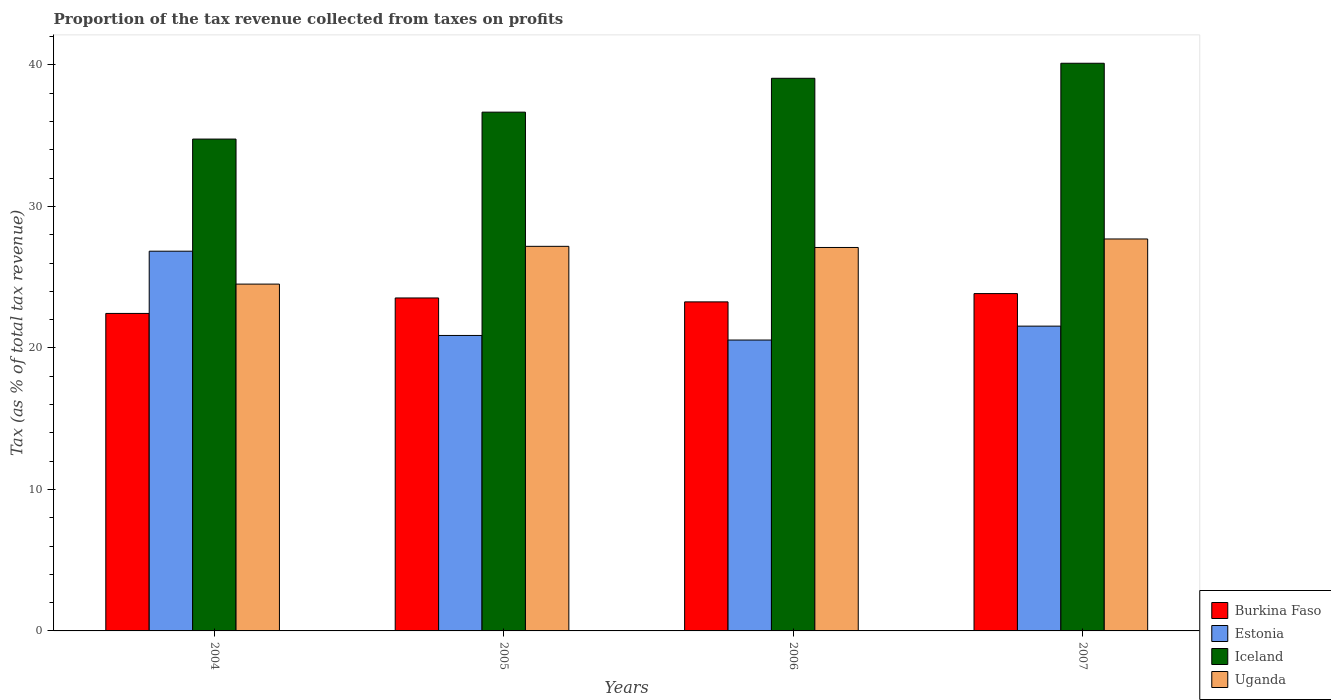How many different coloured bars are there?
Ensure brevity in your answer.  4. How many groups of bars are there?
Provide a succinct answer. 4. How many bars are there on the 4th tick from the right?
Offer a very short reply. 4. What is the proportion of the tax revenue collected in Burkina Faso in 2005?
Give a very brief answer. 23.53. Across all years, what is the maximum proportion of the tax revenue collected in Iceland?
Your answer should be compact. 40.12. Across all years, what is the minimum proportion of the tax revenue collected in Iceland?
Ensure brevity in your answer.  34.76. In which year was the proportion of the tax revenue collected in Iceland minimum?
Provide a succinct answer. 2004. What is the total proportion of the tax revenue collected in Iceland in the graph?
Your answer should be compact. 150.61. What is the difference between the proportion of the tax revenue collected in Estonia in 2006 and that in 2007?
Your answer should be compact. -0.98. What is the difference between the proportion of the tax revenue collected in Iceland in 2005 and the proportion of the tax revenue collected in Uganda in 2006?
Give a very brief answer. 9.56. What is the average proportion of the tax revenue collected in Burkina Faso per year?
Your response must be concise. 23.27. In the year 2006, what is the difference between the proportion of the tax revenue collected in Uganda and proportion of the tax revenue collected in Estonia?
Ensure brevity in your answer.  6.54. What is the ratio of the proportion of the tax revenue collected in Burkina Faso in 2006 to that in 2007?
Keep it short and to the point. 0.98. What is the difference between the highest and the second highest proportion of the tax revenue collected in Iceland?
Your answer should be compact. 1.06. What is the difference between the highest and the lowest proportion of the tax revenue collected in Uganda?
Offer a terse response. 3.19. Is the sum of the proportion of the tax revenue collected in Burkina Faso in 2004 and 2006 greater than the maximum proportion of the tax revenue collected in Uganda across all years?
Your answer should be compact. Yes. Is it the case that in every year, the sum of the proportion of the tax revenue collected in Iceland and proportion of the tax revenue collected in Uganda is greater than the sum of proportion of the tax revenue collected in Estonia and proportion of the tax revenue collected in Burkina Faso?
Provide a short and direct response. Yes. What does the 2nd bar from the left in 2006 represents?
Offer a terse response. Estonia. What does the 3rd bar from the right in 2004 represents?
Provide a succinct answer. Estonia. How many bars are there?
Your response must be concise. 16. How many years are there in the graph?
Ensure brevity in your answer.  4. Does the graph contain any zero values?
Provide a short and direct response. No. How many legend labels are there?
Give a very brief answer. 4. How are the legend labels stacked?
Give a very brief answer. Vertical. What is the title of the graph?
Make the answer very short. Proportion of the tax revenue collected from taxes on profits. Does "Albania" appear as one of the legend labels in the graph?
Offer a very short reply. No. What is the label or title of the Y-axis?
Offer a terse response. Tax (as % of total tax revenue). What is the Tax (as % of total tax revenue) in Burkina Faso in 2004?
Your response must be concise. 22.44. What is the Tax (as % of total tax revenue) in Estonia in 2004?
Your answer should be very brief. 26.84. What is the Tax (as % of total tax revenue) of Iceland in 2004?
Give a very brief answer. 34.76. What is the Tax (as % of total tax revenue) of Uganda in 2004?
Provide a succinct answer. 24.51. What is the Tax (as % of total tax revenue) in Burkina Faso in 2005?
Offer a very short reply. 23.53. What is the Tax (as % of total tax revenue) of Estonia in 2005?
Provide a succinct answer. 20.88. What is the Tax (as % of total tax revenue) in Iceland in 2005?
Your answer should be very brief. 36.66. What is the Tax (as % of total tax revenue) in Uganda in 2005?
Ensure brevity in your answer.  27.18. What is the Tax (as % of total tax revenue) in Burkina Faso in 2006?
Ensure brevity in your answer.  23.26. What is the Tax (as % of total tax revenue) in Estonia in 2006?
Provide a succinct answer. 20.56. What is the Tax (as % of total tax revenue) of Iceland in 2006?
Offer a terse response. 39.06. What is the Tax (as % of total tax revenue) in Uganda in 2006?
Make the answer very short. 27.1. What is the Tax (as % of total tax revenue) in Burkina Faso in 2007?
Give a very brief answer. 23.84. What is the Tax (as % of total tax revenue) in Estonia in 2007?
Offer a terse response. 21.54. What is the Tax (as % of total tax revenue) in Iceland in 2007?
Offer a very short reply. 40.12. What is the Tax (as % of total tax revenue) of Uganda in 2007?
Keep it short and to the point. 27.7. Across all years, what is the maximum Tax (as % of total tax revenue) in Burkina Faso?
Ensure brevity in your answer.  23.84. Across all years, what is the maximum Tax (as % of total tax revenue) of Estonia?
Offer a terse response. 26.84. Across all years, what is the maximum Tax (as % of total tax revenue) in Iceland?
Give a very brief answer. 40.12. Across all years, what is the maximum Tax (as % of total tax revenue) in Uganda?
Offer a terse response. 27.7. Across all years, what is the minimum Tax (as % of total tax revenue) in Burkina Faso?
Ensure brevity in your answer.  22.44. Across all years, what is the minimum Tax (as % of total tax revenue) of Estonia?
Keep it short and to the point. 20.56. Across all years, what is the minimum Tax (as % of total tax revenue) of Iceland?
Offer a very short reply. 34.76. Across all years, what is the minimum Tax (as % of total tax revenue) in Uganda?
Keep it short and to the point. 24.51. What is the total Tax (as % of total tax revenue) in Burkina Faso in the graph?
Make the answer very short. 93.07. What is the total Tax (as % of total tax revenue) of Estonia in the graph?
Provide a succinct answer. 89.82. What is the total Tax (as % of total tax revenue) of Iceland in the graph?
Provide a short and direct response. 150.61. What is the total Tax (as % of total tax revenue) in Uganda in the graph?
Your answer should be compact. 106.5. What is the difference between the Tax (as % of total tax revenue) of Burkina Faso in 2004 and that in 2005?
Keep it short and to the point. -1.09. What is the difference between the Tax (as % of total tax revenue) in Estonia in 2004 and that in 2005?
Provide a succinct answer. 5.96. What is the difference between the Tax (as % of total tax revenue) of Iceland in 2004 and that in 2005?
Provide a succinct answer. -1.9. What is the difference between the Tax (as % of total tax revenue) of Uganda in 2004 and that in 2005?
Your answer should be compact. -2.67. What is the difference between the Tax (as % of total tax revenue) of Burkina Faso in 2004 and that in 2006?
Your response must be concise. -0.82. What is the difference between the Tax (as % of total tax revenue) in Estonia in 2004 and that in 2006?
Offer a very short reply. 6.28. What is the difference between the Tax (as % of total tax revenue) of Iceland in 2004 and that in 2006?
Your answer should be very brief. -4.3. What is the difference between the Tax (as % of total tax revenue) in Uganda in 2004 and that in 2006?
Your answer should be very brief. -2.59. What is the difference between the Tax (as % of total tax revenue) in Burkina Faso in 2004 and that in 2007?
Your response must be concise. -1.4. What is the difference between the Tax (as % of total tax revenue) in Estonia in 2004 and that in 2007?
Your answer should be compact. 5.3. What is the difference between the Tax (as % of total tax revenue) of Iceland in 2004 and that in 2007?
Ensure brevity in your answer.  -5.36. What is the difference between the Tax (as % of total tax revenue) of Uganda in 2004 and that in 2007?
Your answer should be very brief. -3.19. What is the difference between the Tax (as % of total tax revenue) of Burkina Faso in 2005 and that in 2006?
Your answer should be very brief. 0.28. What is the difference between the Tax (as % of total tax revenue) of Estonia in 2005 and that in 2006?
Keep it short and to the point. 0.32. What is the difference between the Tax (as % of total tax revenue) of Iceland in 2005 and that in 2006?
Ensure brevity in your answer.  -2.39. What is the difference between the Tax (as % of total tax revenue) in Uganda in 2005 and that in 2006?
Provide a succinct answer. 0.08. What is the difference between the Tax (as % of total tax revenue) of Burkina Faso in 2005 and that in 2007?
Provide a short and direct response. -0.31. What is the difference between the Tax (as % of total tax revenue) of Estonia in 2005 and that in 2007?
Your answer should be compact. -0.66. What is the difference between the Tax (as % of total tax revenue) of Iceland in 2005 and that in 2007?
Your answer should be very brief. -3.46. What is the difference between the Tax (as % of total tax revenue) in Uganda in 2005 and that in 2007?
Give a very brief answer. -0.52. What is the difference between the Tax (as % of total tax revenue) in Burkina Faso in 2006 and that in 2007?
Give a very brief answer. -0.59. What is the difference between the Tax (as % of total tax revenue) in Estonia in 2006 and that in 2007?
Offer a terse response. -0.98. What is the difference between the Tax (as % of total tax revenue) in Iceland in 2006 and that in 2007?
Provide a short and direct response. -1.06. What is the difference between the Tax (as % of total tax revenue) in Uganda in 2006 and that in 2007?
Provide a succinct answer. -0.6. What is the difference between the Tax (as % of total tax revenue) in Burkina Faso in 2004 and the Tax (as % of total tax revenue) in Estonia in 2005?
Make the answer very short. 1.56. What is the difference between the Tax (as % of total tax revenue) of Burkina Faso in 2004 and the Tax (as % of total tax revenue) of Iceland in 2005?
Provide a succinct answer. -14.23. What is the difference between the Tax (as % of total tax revenue) of Burkina Faso in 2004 and the Tax (as % of total tax revenue) of Uganda in 2005?
Offer a very short reply. -4.74. What is the difference between the Tax (as % of total tax revenue) of Estonia in 2004 and the Tax (as % of total tax revenue) of Iceland in 2005?
Provide a succinct answer. -9.83. What is the difference between the Tax (as % of total tax revenue) of Estonia in 2004 and the Tax (as % of total tax revenue) of Uganda in 2005?
Your response must be concise. -0.34. What is the difference between the Tax (as % of total tax revenue) in Iceland in 2004 and the Tax (as % of total tax revenue) in Uganda in 2005?
Ensure brevity in your answer.  7.58. What is the difference between the Tax (as % of total tax revenue) of Burkina Faso in 2004 and the Tax (as % of total tax revenue) of Estonia in 2006?
Your response must be concise. 1.88. What is the difference between the Tax (as % of total tax revenue) of Burkina Faso in 2004 and the Tax (as % of total tax revenue) of Iceland in 2006?
Provide a succinct answer. -16.62. What is the difference between the Tax (as % of total tax revenue) of Burkina Faso in 2004 and the Tax (as % of total tax revenue) of Uganda in 2006?
Offer a terse response. -4.66. What is the difference between the Tax (as % of total tax revenue) in Estonia in 2004 and the Tax (as % of total tax revenue) in Iceland in 2006?
Offer a very short reply. -12.22. What is the difference between the Tax (as % of total tax revenue) of Estonia in 2004 and the Tax (as % of total tax revenue) of Uganda in 2006?
Provide a succinct answer. -0.26. What is the difference between the Tax (as % of total tax revenue) in Iceland in 2004 and the Tax (as % of total tax revenue) in Uganda in 2006?
Your answer should be very brief. 7.66. What is the difference between the Tax (as % of total tax revenue) in Burkina Faso in 2004 and the Tax (as % of total tax revenue) in Estonia in 2007?
Your answer should be compact. 0.9. What is the difference between the Tax (as % of total tax revenue) in Burkina Faso in 2004 and the Tax (as % of total tax revenue) in Iceland in 2007?
Your answer should be very brief. -17.68. What is the difference between the Tax (as % of total tax revenue) of Burkina Faso in 2004 and the Tax (as % of total tax revenue) of Uganda in 2007?
Provide a succinct answer. -5.26. What is the difference between the Tax (as % of total tax revenue) of Estonia in 2004 and the Tax (as % of total tax revenue) of Iceland in 2007?
Your response must be concise. -13.28. What is the difference between the Tax (as % of total tax revenue) in Estonia in 2004 and the Tax (as % of total tax revenue) in Uganda in 2007?
Your response must be concise. -0.86. What is the difference between the Tax (as % of total tax revenue) of Iceland in 2004 and the Tax (as % of total tax revenue) of Uganda in 2007?
Make the answer very short. 7.06. What is the difference between the Tax (as % of total tax revenue) of Burkina Faso in 2005 and the Tax (as % of total tax revenue) of Estonia in 2006?
Your response must be concise. 2.97. What is the difference between the Tax (as % of total tax revenue) in Burkina Faso in 2005 and the Tax (as % of total tax revenue) in Iceland in 2006?
Your answer should be compact. -15.53. What is the difference between the Tax (as % of total tax revenue) of Burkina Faso in 2005 and the Tax (as % of total tax revenue) of Uganda in 2006?
Your answer should be compact. -3.57. What is the difference between the Tax (as % of total tax revenue) of Estonia in 2005 and the Tax (as % of total tax revenue) of Iceland in 2006?
Your answer should be compact. -18.18. What is the difference between the Tax (as % of total tax revenue) of Estonia in 2005 and the Tax (as % of total tax revenue) of Uganda in 2006?
Keep it short and to the point. -6.22. What is the difference between the Tax (as % of total tax revenue) in Iceland in 2005 and the Tax (as % of total tax revenue) in Uganda in 2006?
Provide a succinct answer. 9.56. What is the difference between the Tax (as % of total tax revenue) of Burkina Faso in 2005 and the Tax (as % of total tax revenue) of Estonia in 2007?
Provide a short and direct response. 1.99. What is the difference between the Tax (as % of total tax revenue) of Burkina Faso in 2005 and the Tax (as % of total tax revenue) of Iceland in 2007?
Make the answer very short. -16.59. What is the difference between the Tax (as % of total tax revenue) in Burkina Faso in 2005 and the Tax (as % of total tax revenue) in Uganda in 2007?
Offer a very short reply. -4.17. What is the difference between the Tax (as % of total tax revenue) of Estonia in 2005 and the Tax (as % of total tax revenue) of Iceland in 2007?
Offer a terse response. -19.24. What is the difference between the Tax (as % of total tax revenue) in Estonia in 2005 and the Tax (as % of total tax revenue) in Uganda in 2007?
Your response must be concise. -6.82. What is the difference between the Tax (as % of total tax revenue) of Iceland in 2005 and the Tax (as % of total tax revenue) of Uganda in 2007?
Your response must be concise. 8.96. What is the difference between the Tax (as % of total tax revenue) in Burkina Faso in 2006 and the Tax (as % of total tax revenue) in Estonia in 2007?
Make the answer very short. 1.71. What is the difference between the Tax (as % of total tax revenue) of Burkina Faso in 2006 and the Tax (as % of total tax revenue) of Iceland in 2007?
Your answer should be compact. -16.87. What is the difference between the Tax (as % of total tax revenue) in Burkina Faso in 2006 and the Tax (as % of total tax revenue) in Uganda in 2007?
Ensure brevity in your answer.  -4.45. What is the difference between the Tax (as % of total tax revenue) in Estonia in 2006 and the Tax (as % of total tax revenue) in Iceland in 2007?
Your answer should be compact. -19.56. What is the difference between the Tax (as % of total tax revenue) in Estonia in 2006 and the Tax (as % of total tax revenue) in Uganda in 2007?
Your answer should be very brief. -7.14. What is the difference between the Tax (as % of total tax revenue) of Iceland in 2006 and the Tax (as % of total tax revenue) of Uganda in 2007?
Ensure brevity in your answer.  11.36. What is the average Tax (as % of total tax revenue) in Burkina Faso per year?
Your answer should be very brief. 23.27. What is the average Tax (as % of total tax revenue) in Estonia per year?
Your answer should be very brief. 22.46. What is the average Tax (as % of total tax revenue) of Iceland per year?
Your answer should be very brief. 37.65. What is the average Tax (as % of total tax revenue) of Uganda per year?
Make the answer very short. 26.62. In the year 2004, what is the difference between the Tax (as % of total tax revenue) in Burkina Faso and Tax (as % of total tax revenue) in Estonia?
Provide a succinct answer. -4.4. In the year 2004, what is the difference between the Tax (as % of total tax revenue) in Burkina Faso and Tax (as % of total tax revenue) in Iceland?
Your answer should be compact. -12.32. In the year 2004, what is the difference between the Tax (as % of total tax revenue) of Burkina Faso and Tax (as % of total tax revenue) of Uganda?
Make the answer very short. -2.07. In the year 2004, what is the difference between the Tax (as % of total tax revenue) in Estonia and Tax (as % of total tax revenue) in Iceland?
Give a very brief answer. -7.93. In the year 2004, what is the difference between the Tax (as % of total tax revenue) of Estonia and Tax (as % of total tax revenue) of Uganda?
Your answer should be compact. 2.33. In the year 2004, what is the difference between the Tax (as % of total tax revenue) in Iceland and Tax (as % of total tax revenue) in Uganda?
Ensure brevity in your answer.  10.25. In the year 2005, what is the difference between the Tax (as % of total tax revenue) in Burkina Faso and Tax (as % of total tax revenue) in Estonia?
Your answer should be compact. 2.65. In the year 2005, what is the difference between the Tax (as % of total tax revenue) of Burkina Faso and Tax (as % of total tax revenue) of Iceland?
Offer a terse response. -13.13. In the year 2005, what is the difference between the Tax (as % of total tax revenue) in Burkina Faso and Tax (as % of total tax revenue) in Uganda?
Keep it short and to the point. -3.65. In the year 2005, what is the difference between the Tax (as % of total tax revenue) in Estonia and Tax (as % of total tax revenue) in Iceland?
Give a very brief answer. -15.78. In the year 2005, what is the difference between the Tax (as % of total tax revenue) in Estonia and Tax (as % of total tax revenue) in Uganda?
Your answer should be compact. -6.3. In the year 2005, what is the difference between the Tax (as % of total tax revenue) in Iceland and Tax (as % of total tax revenue) in Uganda?
Your answer should be compact. 9.48. In the year 2006, what is the difference between the Tax (as % of total tax revenue) of Burkina Faso and Tax (as % of total tax revenue) of Estonia?
Offer a very short reply. 2.7. In the year 2006, what is the difference between the Tax (as % of total tax revenue) of Burkina Faso and Tax (as % of total tax revenue) of Iceland?
Provide a short and direct response. -15.8. In the year 2006, what is the difference between the Tax (as % of total tax revenue) in Burkina Faso and Tax (as % of total tax revenue) in Uganda?
Offer a very short reply. -3.85. In the year 2006, what is the difference between the Tax (as % of total tax revenue) in Estonia and Tax (as % of total tax revenue) in Iceland?
Your answer should be compact. -18.5. In the year 2006, what is the difference between the Tax (as % of total tax revenue) of Estonia and Tax (as % of total tax revenue) of Uganda?
Keep it short and to the point. -6.54. In the year 2006, what is the difference between the Tax (as % of total tax revenue) in Iceland and Tax (as % of total tax revenue) in Uganda?
Your response must be concise. 11.96. In the year 2007, what is the difference between the Tax (as % of total tax revenue) of Burkina Faso and Tax (as % of total tax revenue) of Estonia?
Ensure brevity in your answer.  2.3. In the year 2007, what is the difference between the Tax (as % of total tax revenue) in Burkina Faso and Tax (as % of total tax revenue) in Iceland?
Provide a succinct answer. -16.28. In the year 2007, what is the difference between the Tax (as % of total tax revenue) in Burkina Faso and Tax (as % of total tax revenue) in Uganda?
Offer a very short reply. -3.86. In the year 2007, what is the difference between the Tax (as % of total tax revenue) of Estonia and Tax (as % of total tax revenue) of Iceland?
Your response must be concise. -18.58. In the year 2007, what is the difference between the Tax (as % of total tax revenue) in Estonia and Tax (as % of total tax revenue) in Uganda?
Your answer should be compact. -6.16. In the year 2007, what is the difference between the Tax (as % of total tax revenue) in Iceland and Tax (as % of total tax revenue) in Uganda?
Keep it short and to the point. 12.42. What is the ratio of the Tax (as % of total tax revenue) of Burkina Faso in 2004 to that in 2005?
Ensure brevity in your answer.  0.95. What is the ratio of the Tax (as % of total tax revenue) in Estonia in 2004 to that in 2005?
Your answer should be compact. 1.29. What is the ratio of the Tax (as % of total tax revenue) of Iceland in 2004 to that in 2005?
Provide a short and direct response. 0.95. What is the ratio of the Tax (as % of total tax revenue) of Uganda in 2004 to that in 2005?
Offer a very short reply. 0.9. What is the ratio of the Tax (as % of total tax revenue) of Burkina Faso in 2004 to that in 2006?
Your answer should be compact. 0.96. What is the ratio of the Tax (as % of total tax revenue) in Estonia in 2004 to that in 2006?
Give a very brief answer. 1.31. What is the ratio of the Tax (as % of total tax revenue) of Iceland in 2004 to that in 2006?
Provide a succinct answer. 0.89. What is the ratio of the Tax (as % of total tax revenue) of Uganda in 2004 to that in 2006?
Ensure brevity in your answer.  0.9. What is the ratio of the Tax (as % of total tax revenue) in Estonia in 2004 to that in 2007?
Your answer should be compact. 1.25. What is the ratio of the Tax (as % of total tax revenue) of Iceland in 2004 to that in 2007?
Offer a terse response. 0.87. What is the ratio of the Tax (as % of total tax revenue) of Uganda in 2004 to that in 2007?
Make the answer very short. 0.88. What is the ratio of the Tax (as % of total tax revenue) in Burkina Faso in 2005 to that in 2006?
Offer a very short reply. 1.01. What is the ratio of the Tax (as % of total tax revenue) in Estonia in 2005 to that in 2006?
Ensure brevity in your answer.  1.02. What is the ratio of the Tax (as % of total tax revenue) of Iceland in 2005 to that in 2006?
Make the answer very short. 0.94. What is the ratio of the Tax (as % of total tax revenue) of Uganda in 2005 to that in 2006?
Provide a succinct answer. 1. What is the ratio of the Tax (as % of total tax revenue) in Estonia in 2005 to that in 2007?
Offer a very short reply. 0.97. What is the ratio of the Tax (as % of total tax revenue) in Iceland in 2005 to that in 2007?
Make the answer very short. 0.91. What is the ratio of the Tax (as % of total tax revenue) of Uganda in 2005 to that in 2007?
Your answer should be very brief. 0.98. What is the ratio of the Tax (as % of total tax revenue) in Burkina Faso in 2006 to that in 2007?
Offer a terse response. 0.98. What is the ratio of the Tax (as % of total tax revenue) of Estonia in 2006 to that in 2007?
Your answer should be compact. 0.95. What is the ratio of the Tax (as % of total tax revenue) of Iceland in 2006 to that in 2007?
Make the answer very short. 0.97. What is the ratio of the Tax (as % of total tax revenue) of Uganda in 2006 to that in 2007?
Give a very brief answer. 0.98. What is the difference between the highest and the second highest Tax (as % of total tax revenue) in Burkina Faso?
Ensure brevity in your answer.  0.31. What is the difference between the highest and the second highest Tax (as % of total tax revenue) of Estonia?
Your answer should be compact. 5.3. What is the difference between the highest and the second highest Tax (as % of total tax revenue) of Iceland?
Provide a succinct answer. 1.06. What is the difference between the highest and the second highest Tax (as % of total tax revenue) of Uganda?
Provide a succinct answer. 0.52. What is the difference between the highest and the lowest Tax (as % of total tax revenue) in Burkina Faso?
Offer a very short reply. 1.4. What is the difference between the highest and the lowest Tax (as % of total tax revenue) in Estonia?
Provide a succinct answer. 6.28. What is the difference between the highest and the lowest Tax (as % of total tax revenue) in Iceland?
Your answer should be compact. 5.36. What is the difference between the highest and the lowest Tax (as % of total tax revenue) of Uganda?
Make the answer very short. 3.19. 